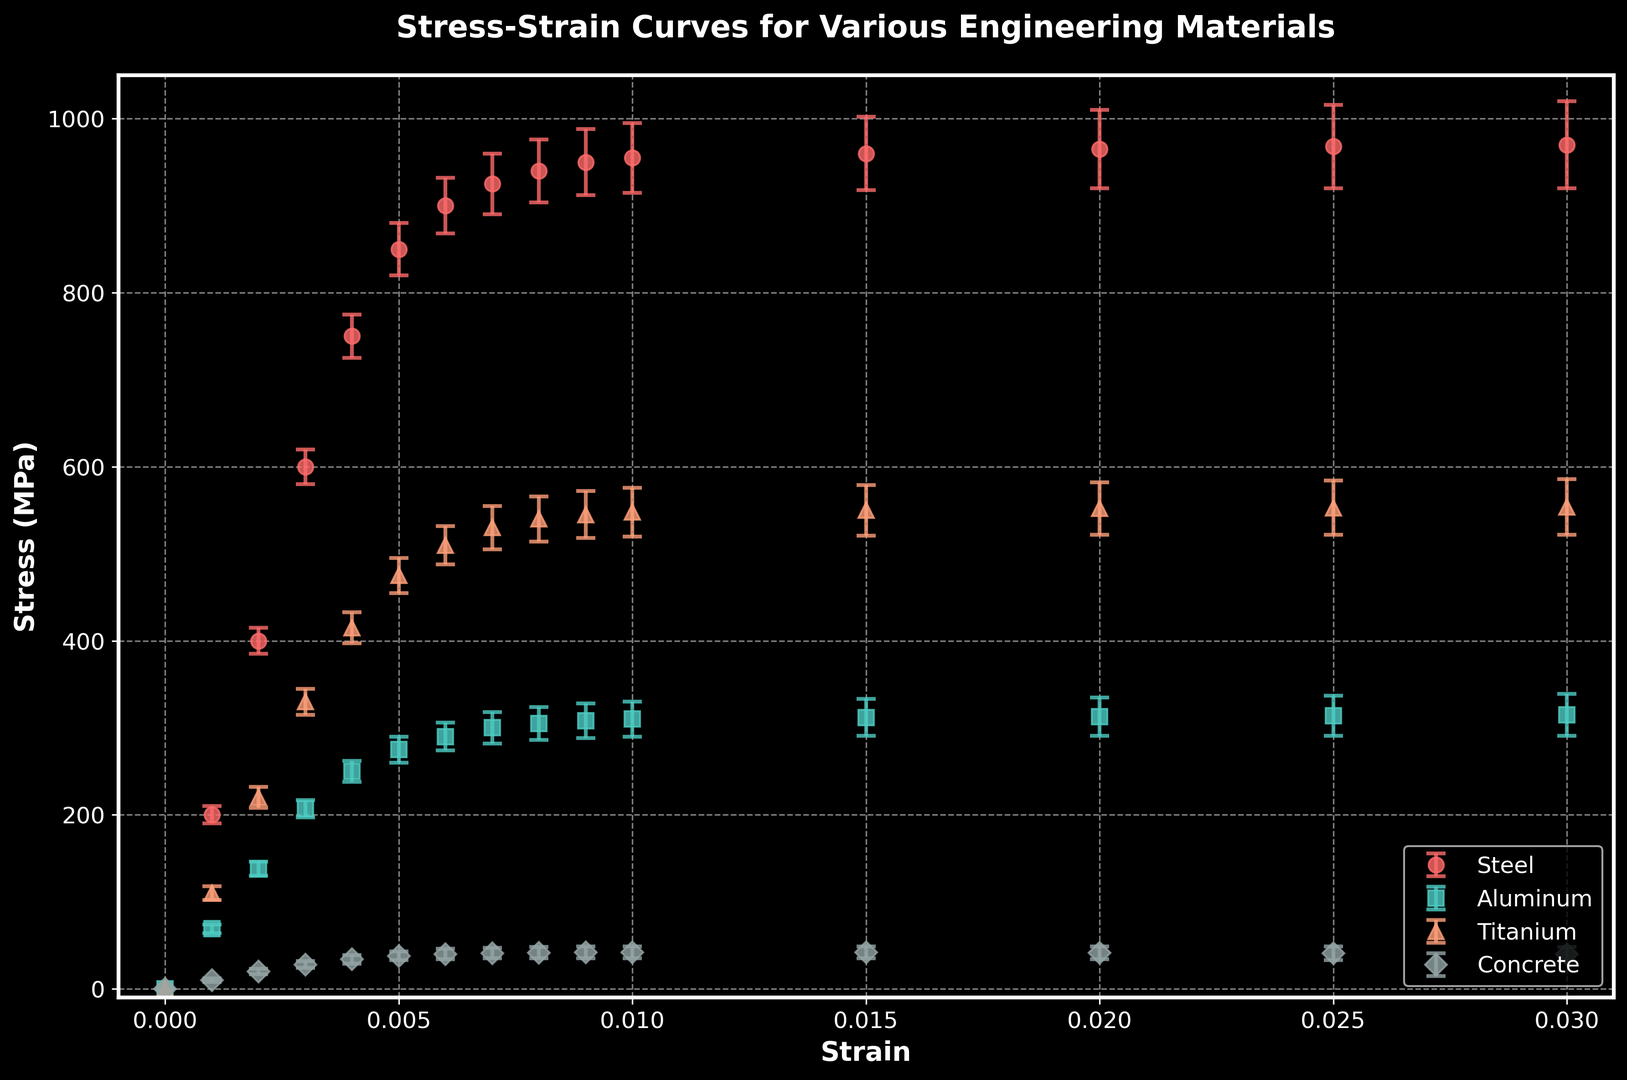What material shows the highest stress at 0.015 strain? Look at the data points for 0.015 strain on the plot and identify which material's curve reaches the highest stress value. In this case, Steel reaches the highest stress value of approximately 960 MPa.
Answer: Steel What is the approximate difference in stress between Aluminum and Titanium at a strain of 0.01? Find the stress values for Aluminum and Titanium at 0.01 strain. Aluminum has a stress of approximately 310 MPa, while Titanium has a stress of about 548 MPa. The difference is 548 - 310 = 238 MPa.
Answer: 238 MPa Which material has the largest variability in stress at a strain of 0.003? Compare the error bars at 0.003 strain for each material. The material with the largest error bar represents the largest variability. Steel shows the largest variability with an error of 20 MPa.
Answer: Steel At what strain value do all materials have error bars overlapping? Identify the strain values where the error bars for all materials overlap. All materials have overlapping error bars between the strain values of 0.005 and 0.007.
Answer: Between 0.005 and 0.007 Compare the average stress values of Concrete and Aluminum for strain values from 0 to 0.01. Which one is higher? Sum up the stress values of Concrete and Aluminum at strain values 0, 0.001, 0.002, 0.003, 0.004, 0.005, 0.006, 0.007, 0.008, 0.009, and 0.01, then calculate their averages. The average Aluminum stress = (0 + 69 + 138 + 207 + 250 + 275 + 290 + 300 + 305 + 308 + 310) / 11 = 249.27 MPa. The average Concrete stress = (0 + 10 + 20 + 28 + 34 + 38 + 40 + 41 + 41.5 + 42 + 42) / 11 = 30.32 MPa. Aluminum has a higher average stress.
Answer: Aluminum What strain value represents the yield point for Steel? Identify the strain value at which Steel's stress curve starts to level off and stops increasing linearly. For Steel, this occurs at around 0.007 strain, where the increase in stress tapers off.
Answer: 0.007 At which strain does Concrete reach its maximum stress? Look at the strain value where Concrete's stress is highest. The maximum concrete stress occurs at strain 0.01 with a value of 42 MPa.
Answer: 0.01 Which material shows the least increase in stress as strain increases from 0 to 0.03? Compare the stress differences from strain 0 to 0.03 for each material. Aluminum has the smallest increase, going from 0 MPa to 315 MPa, an increase of 315 MPa.
Answer: Aluminum How does the error bar size for Titanium compare to Steel at a strain of 0.02? Compare the error bar sizes for Titanium and Steel at 0.02 strain. Titanium's error bar is 30 MPa and Steel's error bar is 45 MPa, so Steel has a larger error bar.
Answer: Steel Which material has the steepest initial stress-strain slope? Identify which material shows the steepest slope in the initial portion of the stress-strain curve. Steel has the highest initial slope as it reaches 200 MPa stress at a strain of 0.001.
Answer: Steel 